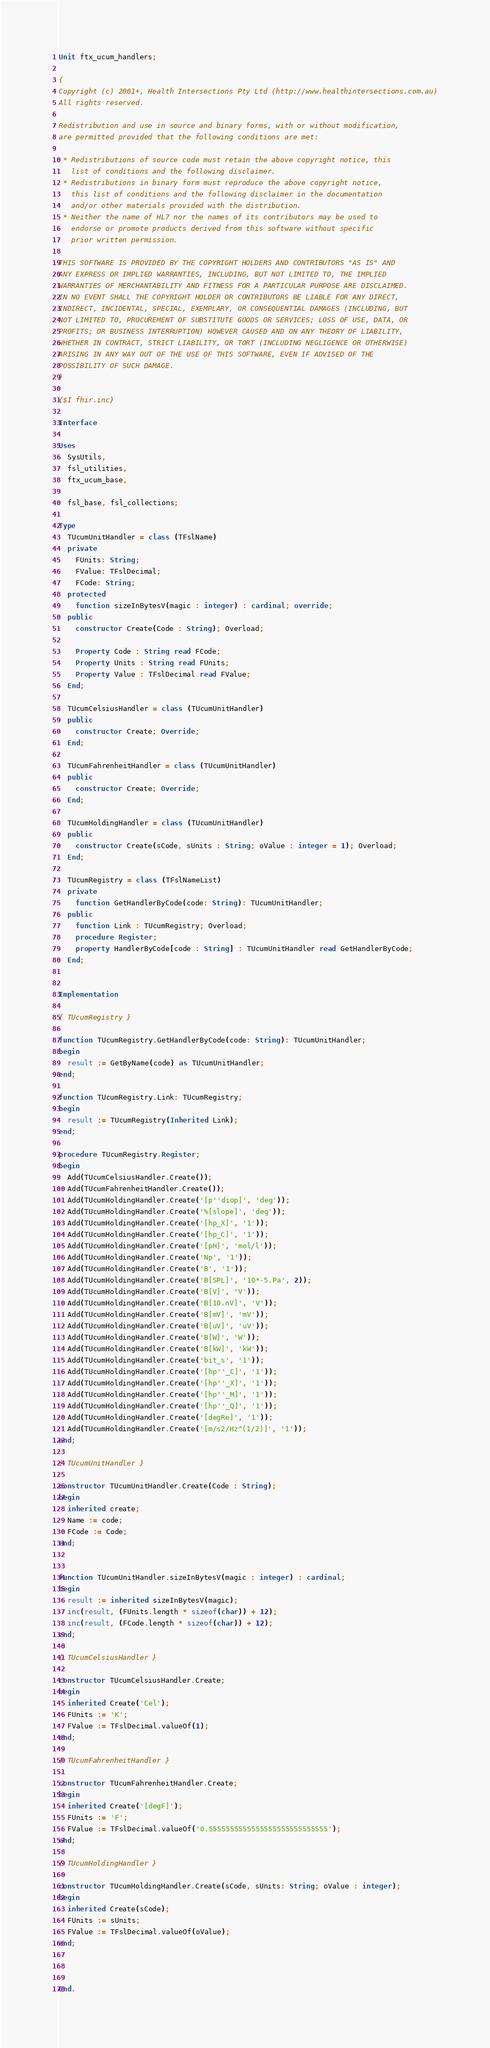<code> <loc_0><loc_0><loc_500><loc_500><_Pascal_>Unit ftx_ucum_handlers;

{
Copyright (c) 2001+, Health Intersections Pty Ltd (http://www.healthintersections.com.au)
All rights reserved.

Redistribution and use in source and binary forms, with or without modification, 
are permitted provided that the following conditions are met:

 * Redistributions of source code must retain the above copyright notice, this 
   list of conditions and the following disclaimer.
 * Redistributions in binary form must reproduce the above copyright notice, 
   this list of conditions and the following disclaimer in the documentation 
   and/or other materials provided with the distribution.
 * Neither the name of HL7 nor the names of its contributors may be used to 
   endorse or promote products derived from this software without specific 
   prior written permission.

THIS SOFTWARE IS PROVIDED BY THE COPYRIGHT HOLDERS AND CONTRIBUTORS "AS IS" AND 
ANY EXPRESS OR IMPLIED WARRANTIES, INCLUDING, BUT NOT LIMITED TO, THE IMPLIED 
WARRANTIES OF MERCHANTABILITY AND FITNESS FOR A PARTICULAR PURPOSE ARE DISCLAIMED. 
IN NO EVENT SHALL THE COPYRIGHT HOLDER OR CONTRIBUTORS BE LIABLE FOR ANY DIRECT, 
INDIRECT, INCIDENTAL, SPECIAL, EXEMPLARY, OR CONSEQUENTIAL DAMAGES (INCLUDING, BUT 
NOT LIMITED TO, PROCUREMENT OF SUBSTITUTE GOODS OR SERVICES; LOSS OF USE, DATA, OR 
PROFITS; OR BUSINESS INTERRUPTION) HOWEVER CAUSED AND ON ANY THEORY OF LIABILITY, 
WHETHER IN CONTRACT, STRICT LIABILITY, OR TORT (INCLUDING NEGLIGENCE OR OTHERWISE) 
ARISING IN ANY WAY OUT OF THE USE OF THIS SOFTWARE, EVEN IF ADVISED OF THE 
POSSIBILITY OF SUCH DAMAGE.
}

{$I fhir.inc}

Interface

Uses
  SysUtils,
  fsl_utilities,
  ftx_ucum_base,
  
  fsl_base, fsl_collections;

Type
  TUcumUnitHandler = class (TFslName)
  private
    FUnits: String;
    FValue: TFslDecimal;
    FCode: String;
  protected
    function sizeInBytesV(magic : integer) : cardinal; override;
  public
    constructor Create(Code : String); Overload;

    Property Code : String read FCode;
    Property Units : String read FUnits;
    Property Value : TFslDecimal read FValue;
  End;

  TUcumCelsiusHandler = class (TUcumUnitHandler)
  public
    constructor Create; Override;
  End;

  TUcumFahrenheitHandler = class (TUcumUnitHandler)
  public
    constructor Create; Override;
  End;

  TUcumHoldingHandler = class (TUcumUnitHandler)
  public
    constructor Create(sCode, sUnits : String; oValue : integer = 1); Overload;
  End;

  TUcumRegistry = class (TFslNameList)
  private
    function GetHandlerByCode(code: String): TUcumUnitHandler;
  public
    function Link : TUcumRegistry; Overload;
    procedure Register;
    property HandlerByCode[code : String] : TUcumUnitHandler read GetHandlerByCode;
  End;


Implementation

{ TUcumRegistry }

function TUcumRegistry.GetHandlerByCode(code: String): TUcumUnitHandler;
begin
  result := GetByName(code) as TUcumUnitHandler;
end;

function TUcumRegistry.Link: TUcumRegistry;
begin
  result := TUcumRegistry(Inherited Link);
end;

procedure TUcumRegistry.Register;
begin
  Add(TUcumCelsiusHandler.Create());
  Add(TUcumFahrenheitHandler.Create());
  Add(TUcumHoldingHandler.Create('[p''diop]', 'deg'));
  Add(TUcumHoldingHandler.Create('%[slope]', 'deg'));
  Add(TUcumHoldingHandler.Create('[hp_X]', '1'));
  Add(TUcumHoldingHandler.Create('[hp_C]', '1'));
  Add(TUcumHoldingHandler.Create('[pH]', 'mol/l'));
  Add(TUcumHoldingHandler.Create('Np', '1'));
  Add(TUcumHoldingHandler.Create('B', '1'));
  Add(TUcumHoldingHandler.Create('B[SPL]', '10*-5.Pa', 2));
  Add(TUcumHoldingHandler.Create('B[V]', 'V'));
  Add(TUcumHoldingHandler.Create('B[10.nV]', 'V'));
  Add(TUcumHoldingHandler.Create('B[mV]', 'mV'));
  Add(TUcumHoldingHandler.Create('B[uV]', 'uV'));
  Add(TUcumHoldingHandler.Create('B[W]', 'W'));
  Add(TUcumHoldingHandler.Create('B[kW]', 'kW'));
  Add(TUcumHoldingHandler.Create('bit_s', '1'));
  Add(TUcumHoldingHandler.Create('[hp''_C]', '1'));
  Add(TUcumHoldingHandler.Create('[hp''_X]', '1'));
  Add(TUcumHoldingHandler.Create('[hp''_M]', '1'));
  Add(TUcumHoldingHandler.Create('[hp''_Q]', '1'));
  Add(TUcumHoldingHandler.Create('[degRe]', '1'));
  Add(TUcumHoldingHandler.Create('[m/s2/Hz^(1/2)]', '1'));
end;

{ TUcumUnitHandler }

constructor TUcumUnitHandler.Create(Code : String);
begin
  inherited create;
  Name := code;
  FCode := Code;
end;


function TUcumUnitHandler.sizeInBytesV(magic : integer) : cardinal;
begin
  result := inherited sizeInBytesV(magic);
  inc(result, (FUnits.length * sizeof(char)) + 12);
  inc(result, (FCode.length * sizeof(char)) + 12);
end;

{ TUcumCelsiusHandler }

constructor TUcumCelsiusHandler.Create;
begin
  inherited Create('Cel');
  FUnits := 'K';
  FValue := TFslDecimal.valueOf(1);
end;

{ TUcumFahrenheitHandler }

constructor TUcumFahrenheitHandler.Create;
begin
  inherited Create('[degF]');
  FUnits := 'F';
  FValue := TFslDecimal.valueOf('0.5555555555555555555555555555');
end;

{ TUcumHoldingHandler }

constructor TUcumHoldingHandler.Create(sCode, sUnits: String; oValue : integer);
begin
  inherited Create(sCode);
  FUnits := sUnits;
  FValue := TFslDecimal.valueOf(oValue);
end;



End.
</code> 